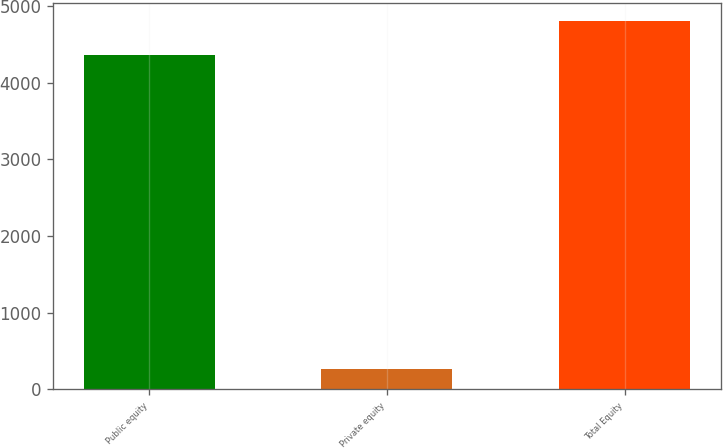Convert chart. <chart><loc_0><loc_0><loc_500><loc_500><bar_chart><fcel>Public equity<fcel>Private equity<fcel>Total Equity<nl><fcel>4371<fcel>258<fcel>4808.1<nl></chart> 